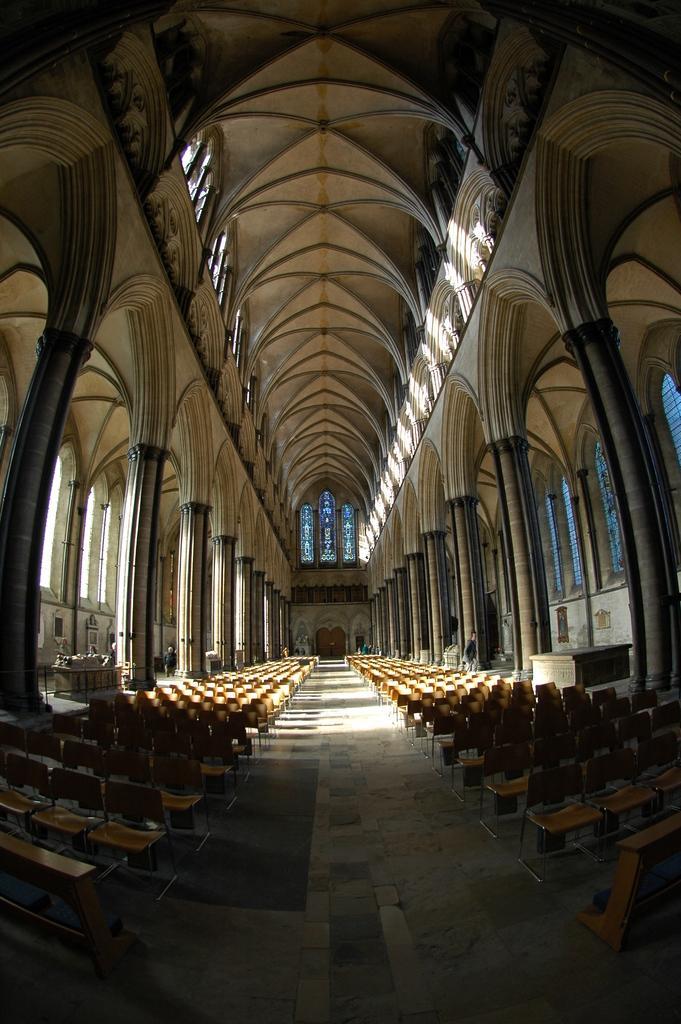In one or two sentences, can you explain what this image depicts? The picture is taken inside a cathedral. In the foreground of the picture we can see chairs, pillars, table, people and various objects. In the background we can see windows and wall. At the top we can see windows and roof. 